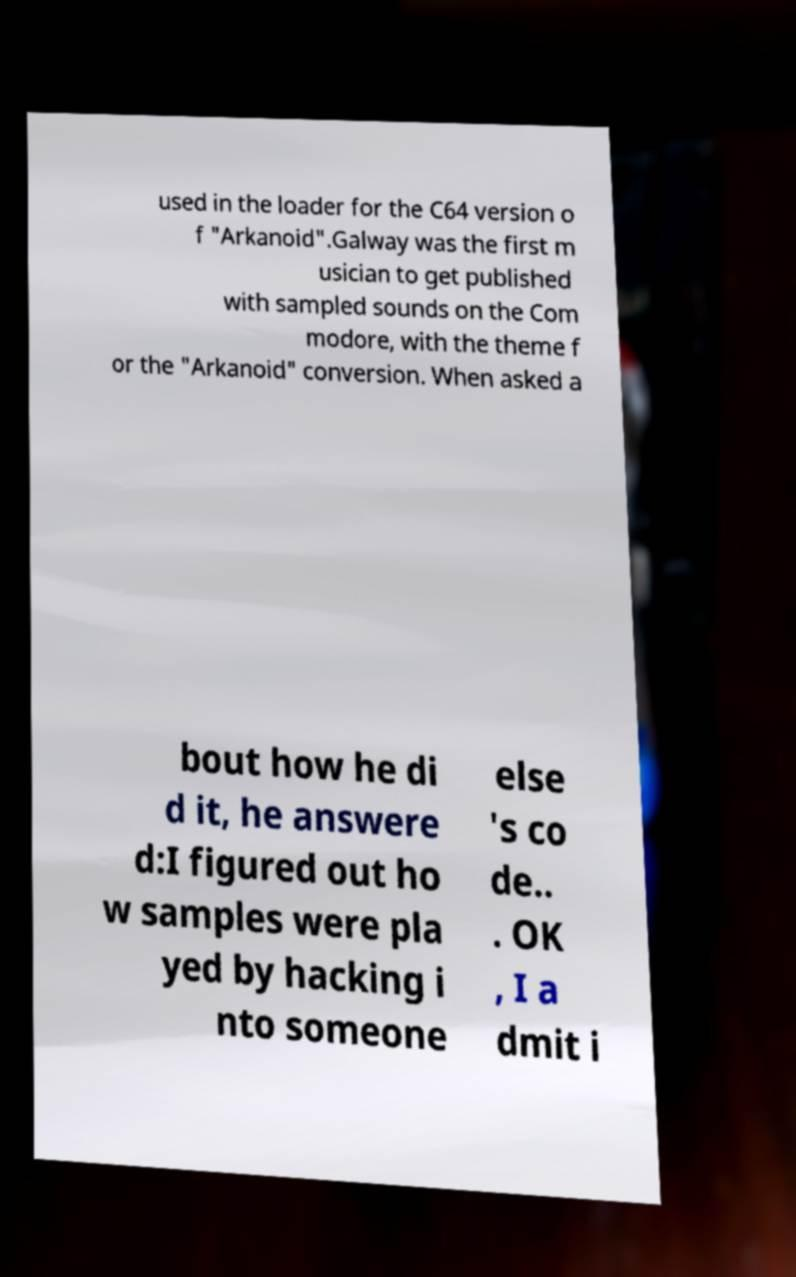Please identify and transcribe the text found in this image. used in the loader for the C64 version o f "Arkanoid".Galway was the first m usician to get published with sampled sounds on the Com modore, with the theme f or the "Arkanoid" conversion. When asked a bout how he di d it, he answere d:I figured out ho w samples were pla yed by hacking i nto someone else 's co de.. . OK , I a dmit i 